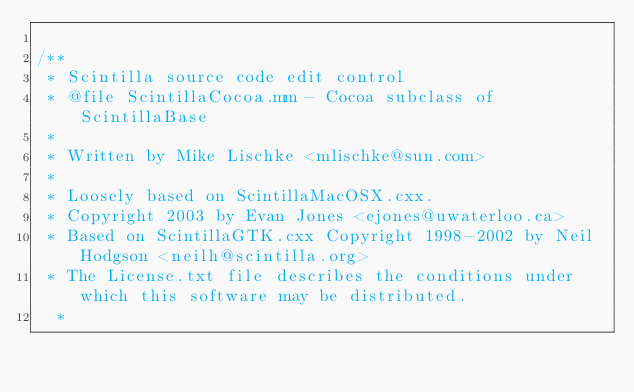<code> <loc_0><loc_0><loc_500><loc_500><_ObjectiveC_>
/**
 * Scintilla source code edit control
 * @file ScintillaCocoa.mm - Cocoa subclass of ScintillaBase
 *
 * Written by Mike Lischke <mlischke@sun.com>
 *
 * Loosely based on ScintillaMacOSX.cxx.
 * Copyright 2003 by Evan Jones <ejones@uwaterloo.ca>
 * Based on ScintillaGTK.cxx Copyright 1998-2002 by Neil Hodgson <neilh@scintilla.org>
 * The License.txt file describes the conditions under which this software may be distributed.
  *</code> 